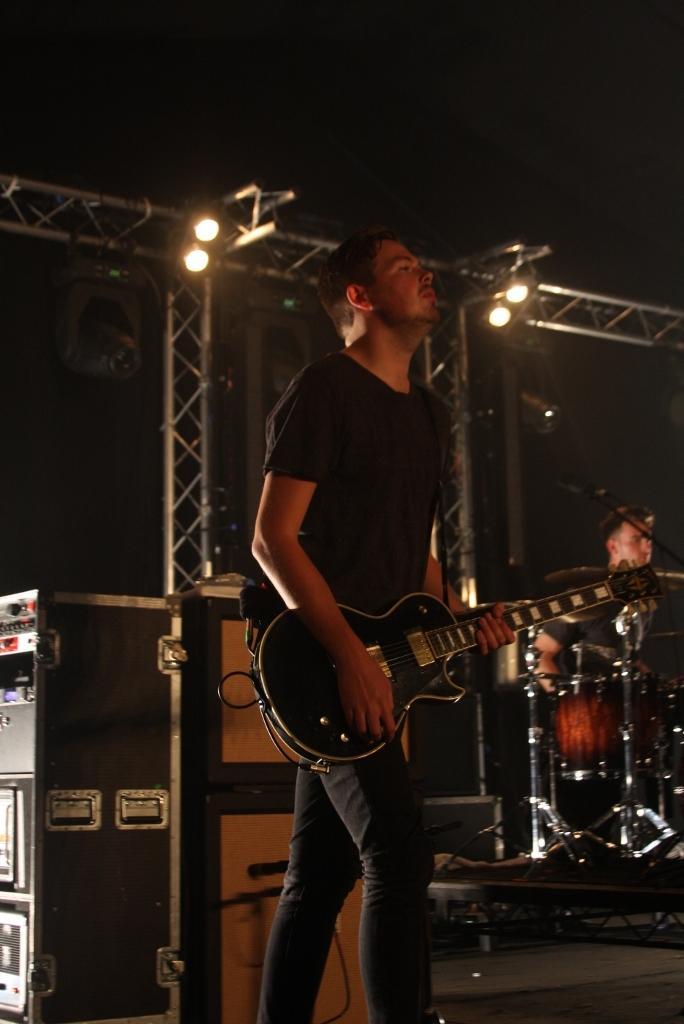Describe this image in one or two sentences. In the center we can see one person,he is playing guitar. And coming to the background we can see some musical instruments along with one person. And on the top we can see lights. 